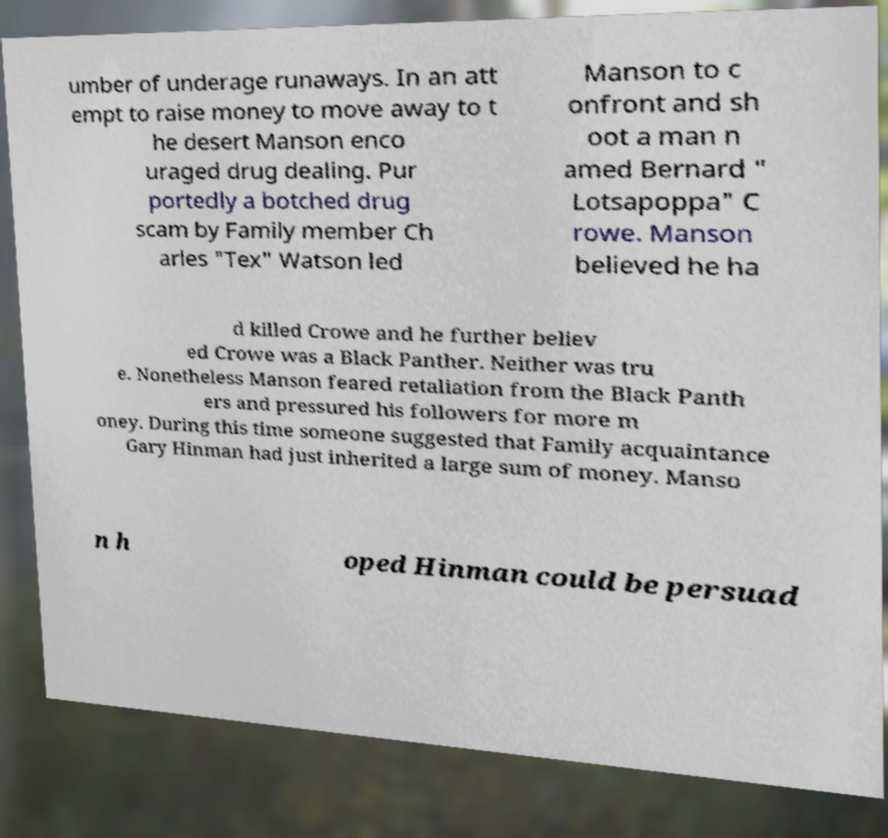For documentation purposes, I need the text within this image transcribed. Could you provide that? umber of underage runaways. In an att empt to raise money to move away to t he desert Manson enco uraged drug dealing. Pur portedly a botched drug scam by Family member Ch arles "Tex" Watson led Manson to c onfront and sh oot a man n amed Bernard " Lotsapoppa" C rowe. Manson believed he ha d killed Crowe and he further believ ed Crowe was a Black Panther. Neither was tru e. Nonetheless Manson feared retaliation from the Black Panth ers and pressured his followers for more m oney. During this time someone suggested that Family acquaintance Gary Hinman had just inherited a large sum of money. Manso n h oped Hinman could be persuad 